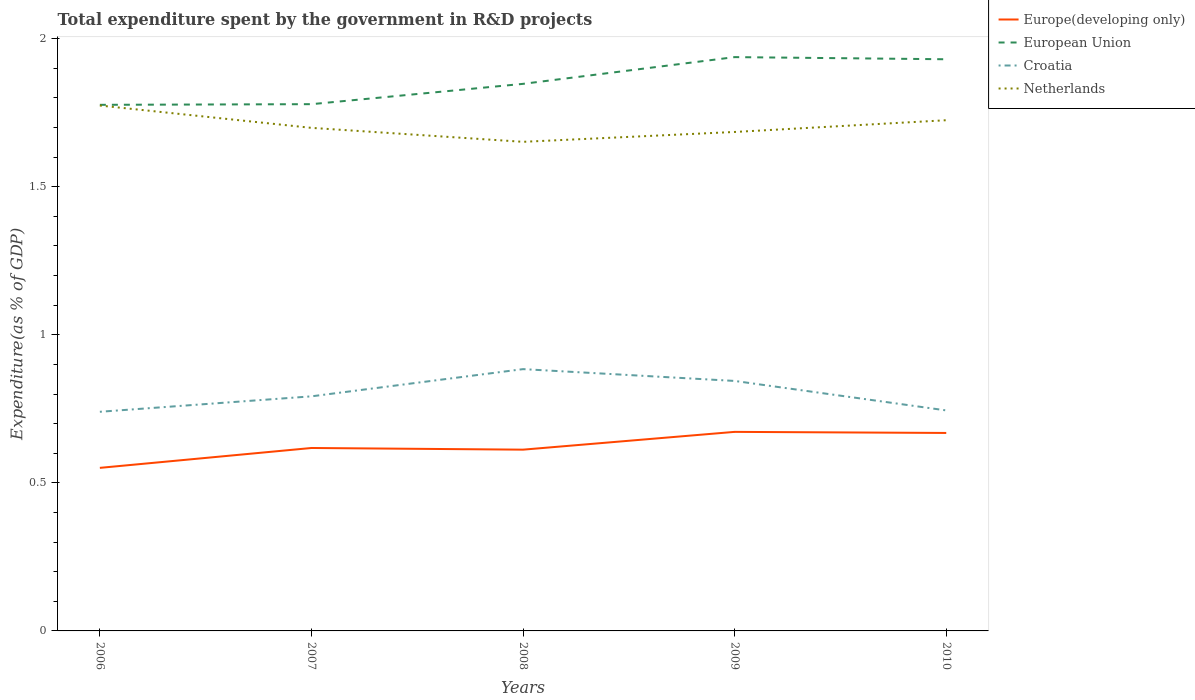How many different coloured lines are there?
Offer a very short reply. 4. Across all years, what is the maximum total expenditure spent by the government in R&D projects in Europe(developing only)?
Your answer should be compact. 0.55. What is the total total expenditure spent by the government in R&D projects in Europe(developing only) in the graph?
Make the answer very short. -0.06. What is the difference between the highest and the second highest total expenditure spent by the government in R&D projects in European Union?
Provide a short and direct response. 0.16. Is the total expenditure spent by the government in R&D projects in Europe(developing only) strictly greater than the total expenditure spent by the government in R&D projects in European Union over the years?
Make the answer very short. Yes. How many lines are there?
Give a very brief answer. 4. What is the difference between two consecutive major ticks on the Y-axis?
Keep it short and to the point. 0.5. Are the values on the major ticks of Y-axis written in scientific E-notation?
Your answer should be compact. No. Does the graph contain any zero values?
Offer a very short reply. No. Where does the legend appear in the graph?
Offer a very short reply. Top right. What is the title of the graph?
Your answer should be very brief. Total expenditure spent by the government in R&D projects. Does "Puerto Rico" appear as one of the legend labels in the graph?
Provide a short and direct response. No. What is the label or title of the Y-axis?
Provide a succinct answer. Expenditure(as % of GDP). What is the Expenditure(as % of GDP) of Europe(developing only) in 2006?
Keep it short and to the point. 0.55. What is the Expenditure(as % of GDP) of European Union in 2006?
Make the answer very short. 1.78. What is the Expenditure(as % of GDP) of Croatia in 2006?
Ensure brevity in your answer.  0.74. What is the Expenditure(as % of GDP) in Netherlands in 2006?
Your answer should be compact. 1.77. What is the Expenditure(as % of GDP) of Europe(developing only) in 2007?
Ensure brevity in your answer.  0.62. What is the Expenditure(as % of GDP) in European Union in 2007?
Ensure brevity in your answer.  1.78. What is the Expenditure(as % of GDP) in Croatia in 2007?
Your answer should be very brief. 0.79. What is the Expenditure(as % of GDP) of Netherlands in 2007?
Provide a succinct answer. 1.7. What is the Expenditure(as % of GDP) in Europe(developing only) in 2008?
Keep it short and to the point. 0.61. What is the Expenditure(as % of GDP) in European Union in 2008?
Make the answer very short. 1.85. What is the Expenditure(as % of GDP) in Croatia in 2008?
Make the answer very short. 0.88. What is the Expenditure(as % of GDP) in Netherlands in 2008?
Your answer should be compact. 1.65. What is the Expenditure(as % of GDP) in Europe(developing only) in 2009?
Give a very brief answer. 0.67. What is the Expenditure(as % of GDP) in European Union in 2009?
Your answer should be very brief. 1.94. What is the Expenditure(as % of GDP) of Croatia in 2009?
Provide a succinct answer. 0.84. What is the Expenditure(as % of GDP) in Netherlands in 2009?
Provide a short and direct response. 1.69. What is the Expenditure(as % of GDP) in Europe(developing only) in 2010?
Make the answer very short. 0.67. What is the Expenditure(as % of GDP) of European Union in 2010?
Your answer should be very brief. 1.93. What is the Expenditure(as % of GDP) in Croatia in 2010?
Make the answer very short. 0.74. What is the Expenditure(as % of GDP) in Netherlands in 2010?
Provide a short and direct response. 1.72. Across all years, what is the maximum Expenditure(as % of GDP) of Europe(developing only)?
Offer a terse response. 0.67. Across all years, what is the maximum Expenditure(as % of GDP) of European Union?
Give a very brief answer. 1.94. Across all years, what is the maximum Expenditure(as % of GDP) of Croatia?
Your answer should be compact. 0.88. Across all years, what is the maximum Expenditure(as % of GDP) in Netherlands?
Make the answer very short. 1.77. Across all years, what is the minimum Expenditure(as % of GDP) of Europe(developing only)?
Provide a succinct answer. 0.55. Across all years, what is the minimum Expenditure(as % of GDP) in European Union?
Make the answer very short. 1.78. Across all years, what is the minimum Expenditure(as % of GDP) of Croatia?
Offer a terse response. 0.74. Across all years, what is the minimum Expenditure(as % of GDP) of Netherlands?
Your response must be concise. 1.65. What is the total Expenditure(as % of GDP) of Europe(developing only) in the graph?
Your answer should be compact. 3.12. What is the total Expenditure(as % of GDP) in European Union in the graph?
Your answer should be compact. 9.27. What is the total Expenditure(as % of GDP) in Croatia in the graph?
Offer a terse response. 4.01. What is the total Expenditure(as % of GDP) of Netherlands in the graph?
Ensure brevity in your answer.  8.54. What is the difference between the Expenditure(as % of GDP) in Europe(developing only) in 2006 and that in 2007?
Provide a succinct answer. -0.07. What is the difference between the Expenditure(as % of GDP) in European Union in 2006 and that in 2007?
Keep it short and to the point. -0. What is the difference between the Expenditure(as % of GDP) in Croatia in 2006 and that in 2007?
Offer a very short reply. -0.05. What is the difference between the Expenditure(as % of GDP) in Netherlands in 2006 and that in 2007?
Make the answer very short. 0.08. What is the difference between the Expenditure(as % of GDP) of Europe(developing only) in 2006 and that in 2008?
Provide a short and direct response. -0.06. What is the difference between the Expenditure(as % of GDP) of European Union in 2006 and that in 2008?
Give a very brief answer. -0.07. What is the difference between the Expenditure(as % of GDP) in Croatia in 2006 and that in 2008?
Offer a very short reply. -0.14. What is the difference between the Expenditure(as % of GDP) in Netherlands in 2006 and that in 2008?
Give a very brief answer. 0.12. What is the difference between the Expenditure(as % of GDP) in Europe(developing only) in 2006 and that in 2009?
Give a very brief answer. -0.12. What is the difference between the Expenditure(as % of GDP) in European Union in 2006 and that in 2009?
Offer a very short reply. -0.16. What is the difference between the Expenditure(as % of GDP) of Croatia in 2006 and that in 2009?
Offer a very short reply. -0.1. What is the difference between the Expenditure(as % of GDP) in Netherlands in 2006 and that in 2009?
Ensure brevity in your answer.  0.09. What is the difference between the Expenditure(as % of GDP) of Europe(developing only) in 2006 and that in 2010?
Offer a terse response. -0.12. What is the difference between the Expenditure(as % of GDP) of European Union in 2006 and that in 2010?
Make the answer very short. -0.15. What is the difference between the Expenditure(as % of GDP) of Croatia in 2006 and that in 2010?
Make the answer very short. -0. What is the difference between the Expenditure(as % of GDP) in Netherlands in 2006 and that in 2010?
Provide a short and direct response. 0.05. What is the difference between the Expenditure(as % of GDP) of Europe(developing only) in 2007 and that in 2008?
Your answer should be compact. 0.01. What is the difference between the Expenditure(as % of GDP) in European Union in 2007 and that in 2008?
Offer a terse response. -0.07. What is the difference between the Expenditure(as % of GDP) of Croatia in 2007 and that in 2008?
Keep it short and to the point. -0.09. What is the difference between the Expenditure(as % of GDP) in Netherlands in 2007 and that in 2008?
Your answer should be compact. 0.05. What is the difference between the Expenditure(as % of GDP) of Europe(developing only) in 2007 and that in 2009?
Your response must be concise. -0.05. What is the difference between the Expenditure(as % of GDP) in European Union in 2007 and that in 2009?
Your answer should be very brief. -0.16. What is the difference between the Expenditure(as % of GDP) of Croatia in 2007 and that in 2009?
Offer a very short reply. -0.05. What is the difference between the Expenditure(as % of GDP) in Netherlands in 2007 and that in 2009?
Offer a very short reply. 0.01. What is the difference between the Expenditure(as % of GDP) in Europe(developing only) in 2007 and that in 2010?
Make the answer very short. -0.05. What is the difference between the Expenditure(as % of GDP) of European Union in 2007 and that in 2010?
Give a very brief answer. -0.15. What is the difference between the Expenditure(as % of GDP) in Croatia in 2007 and that in 2010?
Offer a terse response. 0.05. What is the difference between the Expenditure(as % of GDP) in Netherlands in 2007 and that in 2010?
Keep it short and to the point. -0.03. What is the difference between the Expenditure(as % of GDP) of Europe(developing only) in 2008 and that in 2009?
Give a very brief answer. -0.06. What is the difference between the Expenditure(as % of GDP) of European Union in 2008 and that in 2009?
Your answer should be compact. -0.09. What is the difference between the Expenditure(as % of GDP) in Croatia in 2008 and that in 2009?
Offer a terse response. 0.04. What is the difference between the Expenditure(as % of GDP) of Netherlands in 2008 and that in 2009?
Your answer should be compact. -0.03. What is the difference between the Expenditure(as % of GDP) of Europe(developing only) in 2008 and that in 2010?
Offer a terse response. -0.06. What is the difference between the Expenditure(as % of GDP) of European Union in 2008 and that in 2010?
Provide a succinct answer. -0.08. What is the difference between the Expenditure(as % of GDP) in Croatia in 2008 and that in 2010?
Your response must be concise. 0.14. What is the difference between the Expenditure(as % of GDP) of Netherlands in 2008 and that in 2010?
Offer a very short reply. -0.07. What is the difference between the Expenditure(as % of GDP) of Europe(developing only) in 2009 and that in 2010?
Provide a short and direct response. 0. What is the difference between the Expenditure(as % of GDP) in European Union in 2009 and that in 2010?
Your answer should be very brief. 0.01. What is the difference between the Expenditure(as % of GDP) of Croatia in 2009 and that in 2010?
Ensure brevity in your answer.  0.1. What is the difference between the Expenditure(as % of GDP) in Netherlands in 2009 and that in 2010?
Your answer should be compact. -0.04. What is the difference between the Expenditure(as % of GDP) in Europe(developing only) in 2006 and the Expenditure(as % of GDP) in European Union in 2007?
Ensure brevity in your answer.  -1.23. What is the difference between the Expenditure(as % of GDP) in Europe(developing only) in 2006 and the Expenditure(as % of GDP) in Croatia in 2007?
Offer a terse response. -0.24. What is the difference between the Expenditure(as % of GDP) of Europe(developing only) in 2006 and the Expenditure(as % of GDP) of Netherlands in 2007?
Your answer should be very brief. -1.15. What is the difference between the Expenditure(as % of GDP) in European Union in 2006 and the Expenditure(as % of GDP) in Croatia in 2007?
Give a very brief answer. 0.98. What is the difference between the Expenditure(as % of GDP) in European Union in 2006 and the Expenditure(as % of GDP) in Netherlands in 2007?
Offer a terse response. 0.08. What is the difference between the Expenditure(as % of GDP) of Croatia in 2006 and the Expenditure(as % of GDP) of Netherlands in 2007?
Your answer should be compact. -0.96. What is the difference between the Expenditure(as % of GDP) of Europe(developing only) in 2006 and the Expenditure(as % of GDP) of European Union in 2008?
Provide a short and direct response. -1.3. What is the difference between the Expenditure(as % of GDP) of Europe(developing only) in 2006 and the Expenditure(as % of GDP) of Croatia in 2008?
Offer a very short reply. -0.33. What is the difference between the Expenditure(as % of GDP) in Europe(developing only) in 2006 and the Expenditure(as % of GDP) in Netherlands in 2008?
Offer a terse response. -1.1. What is the difference between the Expenditure(as % of GDP) in European Union in 2006 and the Expenditure(as % of GDP) in Croatia in 2008?
Keep it short and to the point. 0.89. What is the difference between the Expenditure(as % of GDP) of Croatia in 2006 and the Expenditure(as % of GDP) of Netherlands in 2008?
Ensure brevity in your answer.  -0.91. What is the difference between the Expenditure(as % of GDP) of Europe(developing only) in 2006 and the Expenditure(as % of GDP) of European Union in 2009?
Provide a succinct answer. -1.39. What is the difference between the Expenditure(as % of GDP) of Europe(developing only) in 2006 and the Expenditure(as % of GDP) of Croatia in 2009?
Your answer should be compact. -0.29. What is the difference between the Expenditure(as % of GDP) of Europe(developing only) in 2006 and the Expenditure(as % of GDP) of Netherlands in 2009?
Provide a short and direct response. -1.13. What is the difference between the Expenditure(as % of GDP) in European Union in 2006 and the Expenditure(as % of GDP) in Croatia in 2009?
Make the answer very short. 0.93. What is the difference between the Expenditure(as % of GDP) of European Union in 2006 and the Expenditure(as % of GDP) of Netherlands in 2009?
Offer a terse response. 0.09. What is the difference between the Expenditure(as % of GDP) in Croatia in 2006 and the Expenditure(as % of GDP) in Netherlands in 2009?
Provide a short and direct response. -0.94. What is the difference between the Expenditure(as % of GDP) of Europe(developing only) in 2006 and the Expenditure(as % of GDP) of European Union in 2010?
Your response must be concise. -1.38. What is the difference between the Expenditure(as % of GDP) in Europe(developing only) in 2006 and the Expenditure(as % of GDP) in Croatia in 2010?
Provide a succinct answer. -0.19. What is the difference between the Expenditure(as % of GDP) in Europe(developing only) in 2006 and the Expenditure(as % of GDP) in Netherlands in 2010?
Ensure brevity in your answer.  -1.17. What is the difference between the Expenditure(as % of GDP) of European Union in 2006 and the Expenditure(as % of GDP) of Croatia in 2010?
Offer a terse response. 1.03. What is the difference between the Expenditure(as % of GDP) in European Union in 2006 and the Expenditure(as % of GDP) in Netherlands in 2010?
Make the answer very short. 0.05. What is the difference between the Expenditure(as % of GDP) of Croatia in 2006 and the Expenditure(as % of GDP) of Netherlands in 2010?
Offer a very short reply. -0.98. What is the difference between the Expenditure(as % of GDP) in Europe(developing only) in 2007 and the Expenditure(as % of GDP) in European Union in 2008?
Your response must be concise. -1.23. What is the difference between the Expenditure(as % of GDP) in Europe(developing only) in 2007 and the Expenditure(as % of GDP) in Croatia in 2008?
Offer a terse response. -0.27. What is the difference between the Expenditure(as % of GDP) of Europe(developing only) in 2007 and the Expenditure(as % of GDP) of Netherlands in 2008?
Ensure brevity in your answer.  -1.03. What is the difference between the Expenditure(as % of GDP) of European Union in 2007 and the Expenditure(as % of GDP) of Croatia in 2008?
Offer a very short reply. 0.89. What is the difference between the Expenditure(as % of GDP) in European Union in 2007 and the Expenditure(as % of GDP) in Netherlands in 2008?
Your response must be concise. 0.13. What is the difference between the Expenditure(as % of GDP) of Croatia in 2007 and the Expenditure(as % of GDP) of Netherlands in 2008?
Provide a succinct answer. -0.86. What is the difference between the Expenditure(as % of GDP) of Europe(developing only) in 2007 and the Expenditure(as % of GDP) of European Union in 2009?
Your response must be concise. -1.32. What is the difference between the Expenditure(as % of GDP) in Europe(developing only) in 2007 and the Expenditure(as % of GDP) in Croatia in 2009?
Offer a very short reply. -0.23. What is the difference between the Expenditure(as % of GDP) in Europe(developing only) in 2007 and the Expenditure(as % of GDP) in Netherlands in 2009?
Keep it short and to the point. -1.07. What is the difference between the Expenditure(as % of GDP) of European Union in 2007 and the Expenditure(as % of GDP) of Croatia in 2009?
Offer a terse response. 0.93. What is the difference between the Expenditure(as % of GDP) in European Union in 2007 and the Expenditure(as % of GDP) in Netherlands in 2009?
Provide a succinct answer. 0.09. What is the difference between the Expenditure(as % of GDP) in Croatia in 2007 and the Expenditure(as % of GDP) in Netherlands in 2009?
Your answer should be very brief. -0.89. What is the difference between the Expenditure(as % of GDP) of Europe(developing only) in 2007 and the Expenditure(as % of GDP) of European Union in 2010?
Offer a terse response. -1.31. What is the difference between the Expenditure(as % of GDP) in Europe(developing only) in 2007 and the Expenditure(as % of GDP) in Croatia in 2010?
Give a very brief answer. -0.13. What is the difference between the Expenditure(as % of GDP) of Europe(developing only) in 2007 and the Expenditure(as % of GDP) of Netherlands in 2010?
Your response must be concise. -1.11. What is the difference between the Expenditure(as % of GDP) in European Union in 2007 and the Expenditure(as % of GDP) in Croatia in 2010?
Your answer should be very brief. 1.03. What is the difference between the Expenditure(as % of GDP) in European Union in 2007 and the Expenditure(as % of GDP) in Netherlands in 2010?
Provide a succinct answer. 0.05. What is the difference between the Expenditure(as % of GDP) in Croatia in 2007 and the Expenditure(as % of GDP) in Netherlands in 2010?
Your response must be concise. -0.93. What is the difference between the Expenditure(as % of GDP) in Europe(developing only) in 2008 and the Expenditure(as % of GDP) in European Union in 2009?
Offer a very short reply. -1.33. What is the difference between the Expenditure(as % of GDP) in Europe(developing only) in 2008 and the Expenditure(as % of GDP) in Croatia in 2009?
Your answer should be compact. -0.23. What is the difference between the Expenditure(as % of GDP) of Europe(developing only) in 2008 and the Expenditure(as % of GDP) of Netherlands in 2009?
Keep it short and to the point. -1.07. What is the difference between the Expenditure(as % of GDP) of European Union in 2008 and the Expenditure(as % of GDP) of Croatia in 2009?
Offer a very short reply. 1. What is the difference between the Expenditure(as % of GDP) of European Union in 2008 and the Expenditure(as % of GDP) of Netherlands in 2009?
Your answer should be very brief. 0.16. What is the difference between the Expenditure(as % of GDP) of Croatia in 2008 and the Expenditure(as % of GDP) of Netherlands in 2009?
Your answer should be compact. -0.8. What is the difference between the Expenditure(as % of GDP) in Europe(developing only) in 2008 and the Expenditure(as % of GDP) in European Union in 2010?
Give a very brief answer. -1.32. What is the difference between the Expenditure(as % of GDP) in Europe(developing only) in 2008 and the Expenditure(as % of GDP) in Croatia in 2010?
Offer a terse response. -0.13. What is the difference between the Expenditure(as % of GDP) in Europe(developing only) in 2008 and the Expenditure(as % of GDP) in Netherlands in 2010?
Offer a very short reply. -1.11. What is the difference between the Expenditure(as % of GDP) in European Union in 2008 and the Expenditure(as % of GDP) in Croatia in 2010?
Provide a succinct answer. 1.1. What is the difference between the Expenditure(as % of GDP) in European Union in 2008 and the Expenditure(as % of GDP) in Netherlands in 2010?
Offer a terse response. 0.12. What is the difference between the Expenditure(as % of GDP) in Croatia in 2008 and the Expenditure(as % of GDP) in Netherlands in 2010?
Provide a short and direct response. -0.84. What is the difference between the Expenditure(as % of GDP) in Europe(developing only) in 2009 and the Expenditure(as % of GDP) in European Union in 2010?
Provide a short and direct response. -1.26. What is the difference between the Expenditure(as % of GDP) in Europe(developing only) in 2009 and the Expenditure(as % of GDP) in Croatia in 2010?
Your answer should be very brief. -0.07. What is the difference between the Expenditure(as % of GDP) of Europe(developing only) in 2009 and the Expenditure(as % of GDP) of Netherlands in 2010?
Provide a succinct answer. -1.05. What is the difference between the Expenditure(as % of GDP) in European Union in 2009 and the Expenditure(as % of GDP) in Croatia in 2010?
Provide a short and direct response. 1.19. What is the difference between the Expenditure(as % of GDP) in European Union in 2009 and the Expenditure(as % of GDP) in Netherlands in 2010?
Provide a short and direct response. 0.21. What is the difference between the Expenditure(as % of GDP) in Croatia in 2009 and the Expenditure(as % of GDP) in Netherlands in 2010?
Your response must be concise. -0.88. What is the average Expenditure(as % of GDP) in Europe(developing only) per year?
Keep it short and to the point. 0.62. What is the average Expenditure(as % of GDP) of European Union per year?
Offer a terse response. 1.85. What is the average Expenditure(as % of GDP) of Croatia per year?
Your answer should be compact. 0.8. What is the average Expenditure(as % of GDP) of Netherlands per year?
Offer a very short reply. 1.71. In the year 2006, what is the difference between the Expenditure(as % of GDP) in Europe(developing only) and Expenditure(as % of GDP) in European Union?
Your response must be concise. -1.23. In the year 2006, what is the difference between the Expenditure(as % of GDP) in Europe(developing only) and Expenditure(as % of GDP) in Croatia?
Your response must be concise. -0.19. In the year 2006, what is the difference between the Expenditure(as % of GDP) in Europe(developing only) and Expenditure(as % of GDP) in Netherlands?
Provide a succinct answer. -1.22. In the year 2006, what is the difference between the Expenditure(as % of GDP) in European Union and Expenditure(as % of GDP) in Croatia?
Provide a short and direct response. 1.04. In the year 2006, what is the difference between the Expenditure(as % of GDP) of European Union and Expenditure(as % of GDP) of Netherlands?
Your answer should be compact. 0. In the year 2006, what is the difference between the Expenditure(as % of GDP) of Croatia and Expenditure(as % of GDP) of Netherlands?
Provide a succinct answer. -1.03. In the year 2007, what is the difference between the Expenditure(as % of GDP) of Europe(developing only) and Expenditure(as % of GDP) of European Union?
Offer a very short reply. -1.16. In the year 2007, what is the difference between the Expenditure(as % of GDP) of Europe(developing only) and Expenditure(as % of GDP) of Croatia?
Your answer should be compact. -0.17. In the year 2007, what is the difference between the Expenditure(as % of GDP) in Europe(developing only) and Expenditure(as % of GDP) in Netherlands?
Your answer should be very brief. -1.08. In the year 2007, what is the difference between the Expenditure(as % of GDP) in European Union and Expenditure(as % of GDP) in Croatia?
Offer a terse response. 0.99. In the year 2007, what is the difference between the Expenditure(as % of GDP) in European Union and Expenditure(as % of GDP) in Netherlands?
Your answer should be compact. 0.08. In the year 2007, what is the difference between the Expenditure(as % of GDP) in Croatia and Expenditure(as % of GDP) in Netherlands?
Keep it short and to the point. -0.91. In the year 2008, what is the difference between the Expenditure(as % of GDP) of Europe(developing only) and Expenditure(as % of GDP) of European Union?
Ensure brevity in your answer.  -1.24. In the year 2008, what is the difference between the Expenditure(as % of GDP) of Europe(developing only) and Expenditure(as % of GDP) of Croatia?
Make the answer very short. -0.27. In the year 2008, what is the difference between the Expenditure(as % of GDP) of Europe(developing only) and Expenditure(as % of GDP) of Netherlands?
Your answer should be very brief. -1.04. In the year 2008, what is the difference between the Expenditure(as % of GDP) of European Union and Expenditure(as % of GDP) of Croatia?
Keep it short and to the point. 0.96. In the year 2008, what is the difference between the Expenditure(as % of GDP) of European Union and Expenditure(as % of GDP) of Netherlands?
Your answer should be compact. 0.2. In the year 2008, what is the difference between the Expenditure(as % of GDP) of Croatia and Expenditure(as % of GDP) of Netherlands?
Your answer should be very brief. -0.77. In the year 2009, what is the difference between the Expenditure(as % of GDP) in Europe(developing only) and Expenditure(as % of GDP) in European Union?
Your response must be concise. -1.27. In the year 2009, what is the difference between the Expenditure(as % of GDP) in Europe(developing only) and Expenditure(as % of GDP) in Croatia?
Keep it short and to the point. -0.17. In the year 2009, what is the difference between the Expenditure(as % of GDP) of Europe(developing only) and Expenditure(as % of GDP) of Netherlands?
Your response must be concise. -1.01. In the year 2009, what is the difference between the Expenditure(as % of GDP) of European Union and Expenditure(as % of GDP) of Croatia?
Your answer should be compact. 1.09. In the year 2009, what is the difference between the Expenditure(as % of GDP) in European Union and Expenditure(as % of GDP) in Netherlands?
Offer a very short reply. 0.25. In the year 2009, what is the difference between the Expenditure(as % of GDP) in Croatia and Expenditure(as % of GDP) in Netherlands?
Offer a terse response. -0.84. In the year 2010, what is the difference between the Expenditure(as % of GDP) in Europe(developing only) and Expenditure(as % of GDP) in European Union?
Ensure brevity in your answer.  -1.26. In the year 2010, what is the difference between the Expenditure(as % of GDP) of Europe(developing only) and Expenditure(as % of GDP) of Croatia?
Make the answer very short. -0.08. In the year 2010, what is the difference between the Expenditure(as % of GDP) of Europe(developing only) and Expenditure(as % of GDP) of Netherlands?
Make the answer very short. -1.06. In the year 2010, what is the difference between the Expenditure(as % of GDP) in European Union and Expenditure(as % of GDP) in Croatia?
Give a very brief answer. 1.19. In the year 2010, what is the difference between the Expenditure(as % of GDP) in European Union and Expenditure(as % of GDP) in Netherlands?
Give a very brief answer. 0.21. In the year 2010, what is the difference between the Expenditure(as % of GDP) of Croatia and Expenditure(as % of GDP) of Netherlands?
Ensure brevity in your answer.  -0.98. What is the ratio of the Expenditure(as % of GDP) in Europe(developing only) in 2006 to that in 2007?
Ensure brevity in your answer.  0.89. What is the ratio of the Expenditure(as % of GDP) of Croatia in 2006 to that in 2007?
Keep it short and to the point. 0.93. What is the ratio of the Expenditure(as % of GDP) in Netherlands in 2006 to that in 2007?
Offer a very short reply. 1.04. What is the ratio of the Expenditure(as % of GDP) of Europe(developing only) in 2006 to that in 2008?
Provide a succinct answer. 0.9. What is the ratio of the Expenditure(as % of GDP) of European Union in 2006 to that in 2008?
Offer a very short reply. 0.96. What is the ratio of the Expenditure(as % of GDP) in Croatia in 2006 to that in 2008?
Offer a very short reply. 0.84. What is the ratio of the Expenditure(as % of GDP) in Netherlands in 2006 to that in 2008?
Ensure brevity in your answer.  1.07. What is the ratio of the Expenditure(as % of GDP) of Europe(developing only) in 2006 to that in 2009?
Offer a very short reply. 0.82. What is the ratio of the Expenditure(as % of GDP) of European Union in 2006 to that in 2009?
Provide a succinct answer. 0.92. What is the ratio of the Expenditure(as % of GDP) of Croatia in 2006 to that in 2009?
Your response must be concise. 0.88. What is the ratio of the Expenditure(as % of GDP) of Netherlands in 2006 to that in 2009?
Your answer should be compact. 1.05. What is the ratio of the Expenditure(as % of GDP) of Europe(developing only) in 2006 to that in 2010?
Ensure brevity in your answer.  0.82. What is the ratio of the Expenditure(as % of GDP) of European Union in 2006 to that in 2010?
Make the answer very short. 0.92. What is the ratio of the Expenditure(as % of GDP) in Croatia in 2006 to that in 2010?
Ensure brevity in your answer.  0.99. What is the ratio of the Expenditure(as % of GDP) of Netherlands in 2006 to that in 2010?
Provide a short and direct response. 1.03. What is the ratio of the Expenditure(as % of GDP) in Europe(developing only) in 2007 to that in 2008?
Your answer should be very brief. 1.01. What is the ratio of the Expenditure(as % of GDP) in European Union in 2007 to that in 2008?
Make the answer very short. 0.96. What is the ratio of the Expenditure(as % of GDP) of Croatia in 2007 to that in 2008?
Ensure brevity in your answer.  0.9. What is the ratio of the Expenditure(as % of GDP) of Netherlands in 2007 to that in 2008?
Your answer should be compact. 1.03. What is the ratio of the Expenditure(as % of GDP) in Europe(developing only) in 2007 to that in 2009?
Your response must be concise. 0.92. What is the ratio of the Expenditure(as % of GDP) of European Union in 2007 to that in 2009?
Ensure brevity in your answer.  0.92. What is the ratio of the Expenditure(as % of GDP) in Croatia in 2007 to that in 2009?
Make the answer very short. 0.94. What is the ratio of the Expenditure(as % of GDP) in Netherlands in 2007 to that in 2009?
Keep it short and to the point. 1.01. What is the ratio of the Expenditure(as % of GDP) of Europe(developing only) in 2007 to that in 2010?
Your answer should be compact. 0.92. What is the ratio of the Expenditure(as % of GDP) of European Union in 2007 to that in 2010?
Offer a very short reply. 0.92. What is the ratio of the Expenditure(as % of GDP) in Croatia in 2007 to that in 2010?
Keep it short and to the point. 1.06. What is the ratio of the Expenditure(as % of GDP) in Europe(developing only) in 2008 to that in 2009?
Your answer should be very brief. 0.91. What is the ratio of the Expenditure(as % of GDP) of European Union in 2008 to that in 2009?
Make the answer very short. 0.95. What is the ratio of the Expenditure(as % of GDP) of Croatia in 2008 to that in 2009?
Make the answer very short. 1.05. What is the ratio of the Expenditure(as % of GDP) in Netherlands in 2008 to that in 2009?
Ensure brevity in your answer.  0.98. What is the ratio of the Expenditure(as % of GDP) of Europe(developing only) in 2008 to that in 2010?
Your response must be concise. 0.92. What is the ratio of the Expenditure(as % of GDP) in Croatia in 2008 to that in 2010?
Give a very brief answer. 1.19. What is the ratio of the Expenditure(as % of GDP) in Netherlands in 2008 to that in 2010?
Ensure brevity in your answer.  0.96. What is the ratio of the Expenditure(as % of GDP) of Europe(developing only) in 2009 to that in 2010?
Your response must be concise. 1.01. What is the ratio of the Expenditure(as % of GDP) in Croatia in 2009 to that in 2010?
Ensure brevity in your answer.  1.13. What is the ratio of the Expenditure(as % of GDP) in Netherlands in 2009 to that in 2010?
Offer a very short reply. 0.98. What is the difference between the highest and the second highest Expenditure(as % of GDP) in Europe(developing only)?
Your answer should be very brief. 0. What is the difference between the highest and the second highest Expenditure(as % of GDP) of European Union?
Make the answer very short. 0.01. What is the difference between the highest and the second highest Expenditure(as % of GDP) in Croatia?
Provide a short and direct response. 0.04. What is the difference between the highest and the second highest Expenditure(as % of GDP) in Netherlands?
Ensure brevity in your answer.  0.05. What is the difference between the highest and the lowest Expenditure(as % of GDP) of Europe(developing only)?
Give a very brief answer. 0.12. What is the difference between the highest and the lowest Expenditure(as % of GDP) in European Union?
Offer a terse response. 0.16. What is the difference between the highest and the lowest Expenditure(as % of GDP) of Croatia?
Provide a short and direct response. 0.14. What is the difference between the highest and the lowest Expenditure(as % of GDP) of Netherlands?
Your response must be concise. 0.12. 